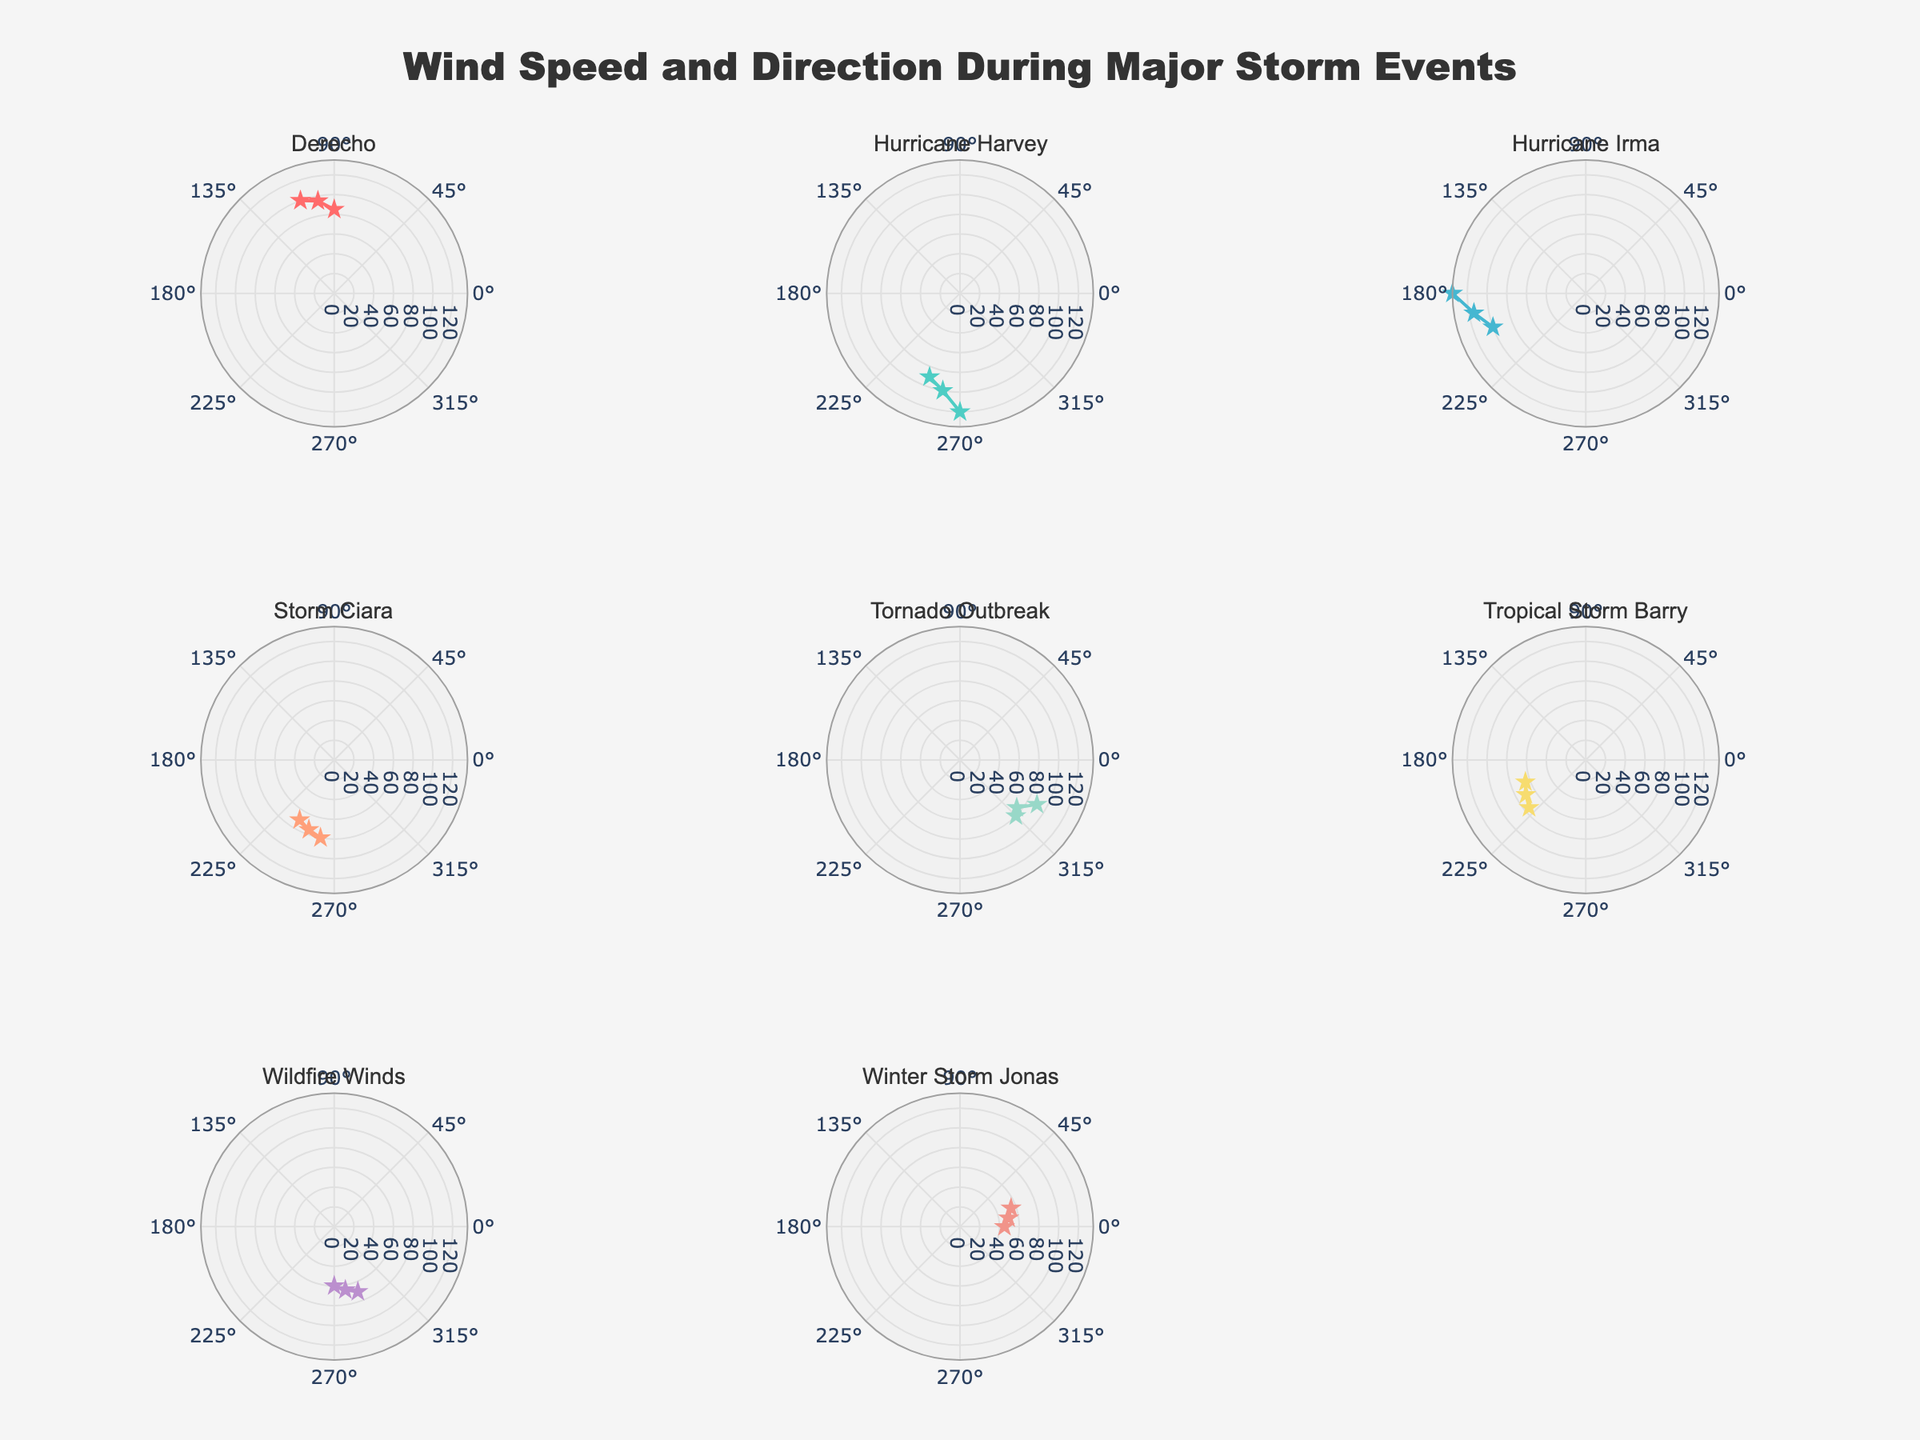How many storm events are represented in the plot? The figure includes a subplot for each unique storm event. By counting the subplot titles, we can determine the number of distinct storm events.
Answer: 8 Which storm event has the highest wind speed recorded? Identify the subplot with the highest radial distance from the center, representing the highest wind speed. Look for the maximum radial value among all subplots.
Answer: Hurricane Irma How does the wind direction vary for Hurricane Harvey compared to Tornado Outbreak? Examine the angles (theta) of the data points in both subplots. Compare the range of directions from each storm event by observing their angular positions.
Answer: Hurricane Harvey: 250° to 270°, Tornado Outbreak: 315° to 330° What is the average wind speed recorded during Winter Storm Jonas? Add the wind speeds recorded in Winter Storm Jonas and divide by the number of observations. Sum of wind speeds: 45 + 50 + 55 = 150. Number of observations: 3. Therefore, the average wind speed is 150 / 3.
Answer: 50 mph Which storm event occurred in the month of February, and what was the range of wind speeds for this event? Identify the subplot corresponding to February from the subplot titles. Then check the radial distances and list the minimum and maximum wind speeds.
Answer: Storm Ciara, 70 mph to 80 mph Which month had the most diverse wind directions represented across different storm events? Compare the angular range covered by each month's subplots. Count the number of different wind directions within each month and identify the month with the widest range.
Answer: August How does Wind Speed during Derecho in June compare to Tropical Storm Barry in July? Look at the radial distances for both events' subplots and compare their ranges. Derecho ranges from 85 mph to 100 mph, and Tropical Storm Barry ranges from 65 mph to 75 mph.
Answer: Derecho generally has higher wind speeds than Tropical Storm Barry What is the overall pattern of wind speeds for Wildfire Winds in October? Observe the radial distances (wind speeds) in the subplot for Wildfire Winds and describe the trend. Look for whether the values increase, decrease, or are consistent.
Answer: Wind speeds increase from 60 mph to 70 mph What direction did Hurricane Irma's winds come from, based on the figure? Check the angles (theta) in the Hurricane Irma subplot, which represent wind directions.
Answer: 180° to 200° For the subplot title "Derecho," what is the wind speed recorded at the direction of 100°? Locate the data point at 100° in the Derecho subplot and note the corresponding radial distance (wind speed).
Answer: 95 mph 